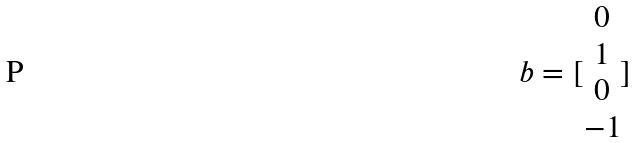<formula> <loc_0><loc_0><loc_500><loc_500>b = [ \begin{matrix} 0 \\ 1 \\ 0 \\ - 1 \end{matrix} ]</formula> 